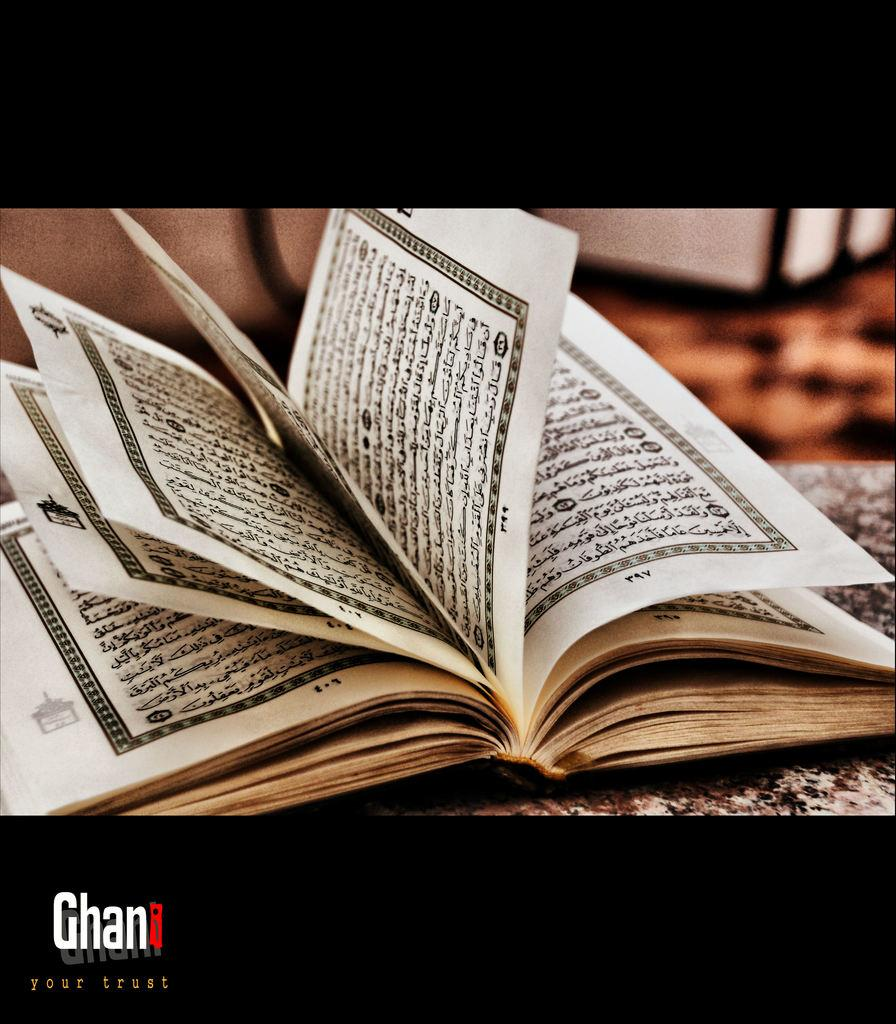<image>
Create a compact narrative representing the image presented. An open book has the pages leafted open on the Ghani page. 